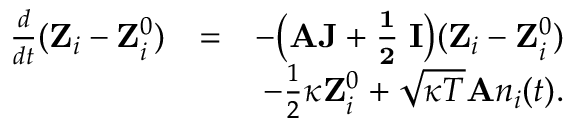<formula> <loc_0><loc_0><loc_500><loc_500>\begin{array} { r l r } { \frac { d } { d t } ( { Z } _ { i } - { Z } _ { i } ^ { 0 } ) } & { = } & { - \left ( { A J + \frac { 1 } { 2 } \kappa I } \right ) ( { Z } _ { i } - { Z } _ { i } ^ { 0 } ) } \\ & { - \frac { 1 } { 2 } \kappa { Z } _ { i } ^ { 0 } + \sqrt { \kappa T } { A } n _ { i } ( t ) . } \end{array}</formula> 